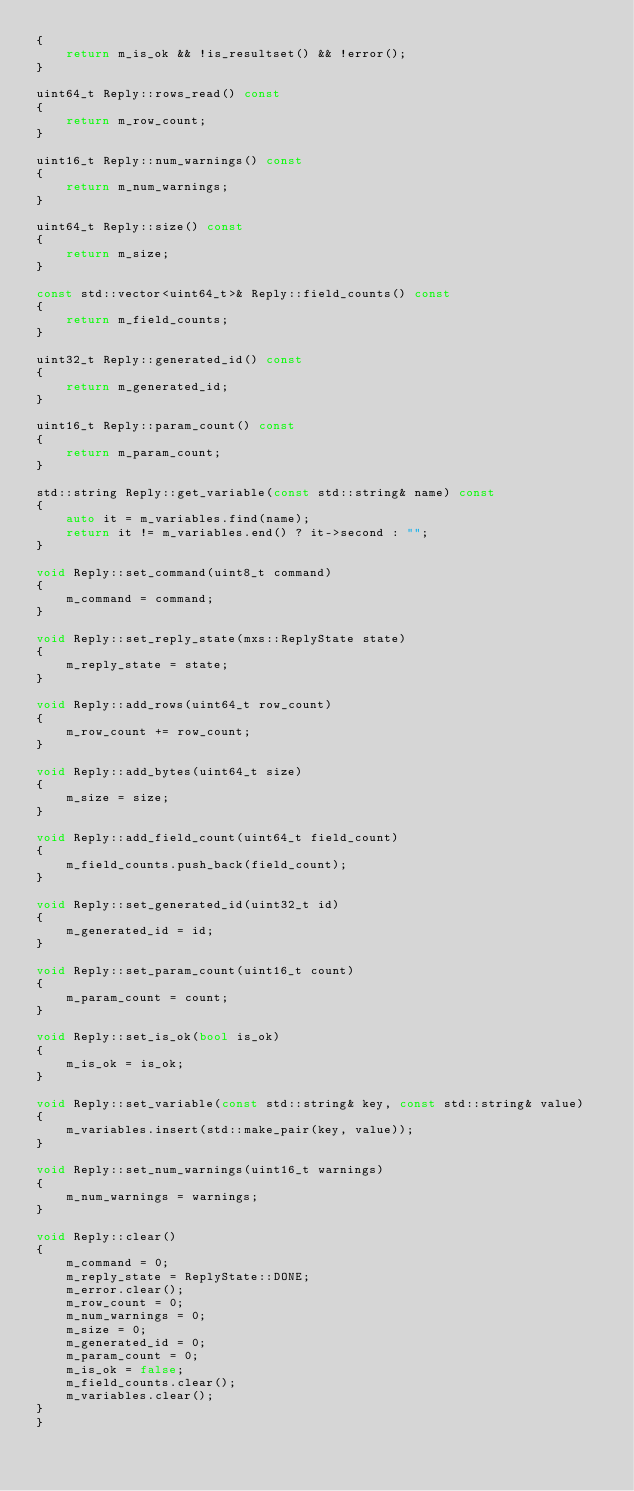Convert code to text. <code><loc_0><loc_0><loc_500><loc_500><_C++_>{
    return m_is_ok && !is_resultset() && !error();
}

uint64_t Reply::rows_read() const
{
    return m_row_count;
}

uint16_t Reply::num_warnings() const
{
    return m_num_warnings;
}

uint64_t Reply::size() const
{
    return m_size;
}

const std::vector<uint64_t>& Reply::field_counts() const
{
    return m_field_counts;
}

uint32_t Reply::generated_id() const
{
    return m_generated_id;
}

uint16_t Reply::param_count() const
{
    return m_param_count;
}

std::string Reply::get_variable(const std::string& name) const
{
    auto it = m_variables.find(name);
    return it != m_variables.end() ? it->second : "";
}

void Reply::set_command(uint8_t command)
{
    m_command = command;
}

void Reply::set_reply_state(mxs::ReplyState state)
{
    m_reply_state = state;
}

void Reply::add_rows(uint64_t row_count)
{
    m_row_count += row_count;
}

void Reply::add_bytes(uint64_t size)
{
    m_size = size;
}

void Reply::add_field_count(uint64_t field_count)
{
    m_field_counts.push_back(field_count);
}

void Reply::set_generated_id(uint32_t id)
{
    m_generated_id = id;
}

void Reply::set_param_count(uint16_t count)
{
    m_param_count = count;
}

void Reply::set_is_ok(bool is_ok)
{
    m_is_ok = is_ok;
}

void Reply::set_variable(const std::string& key, const std::string& value)
{
    m_variables.insert(std::make_pair(key, value));
}

void Reply::set_num_warnings(uint16_t warnings)
{
    m_num_warnings = warnings;
}

void Reply::clear()
{
    m_command = 0;
    m_reply_state = ReplyState::DONE;
    m_error.clear();
    m_row_count = 0;
    m_num_warnings = 0;
    m_size = 0;
    m_generated_id = 0;
    m_param_count = 0;
    m_is_ok = false;
    m_field_counts.clear();
    m_variables.clear();
}
}
</code> 